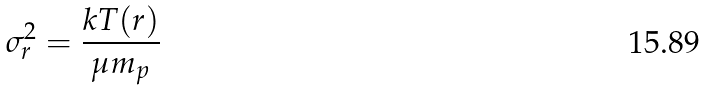<formula> <loc_0><loc_0><loc_500><loc_500>\sigma ^ { 2 } _ { r } = \frac { k T ( r ) } { \mu m _ { p } }</formula> 